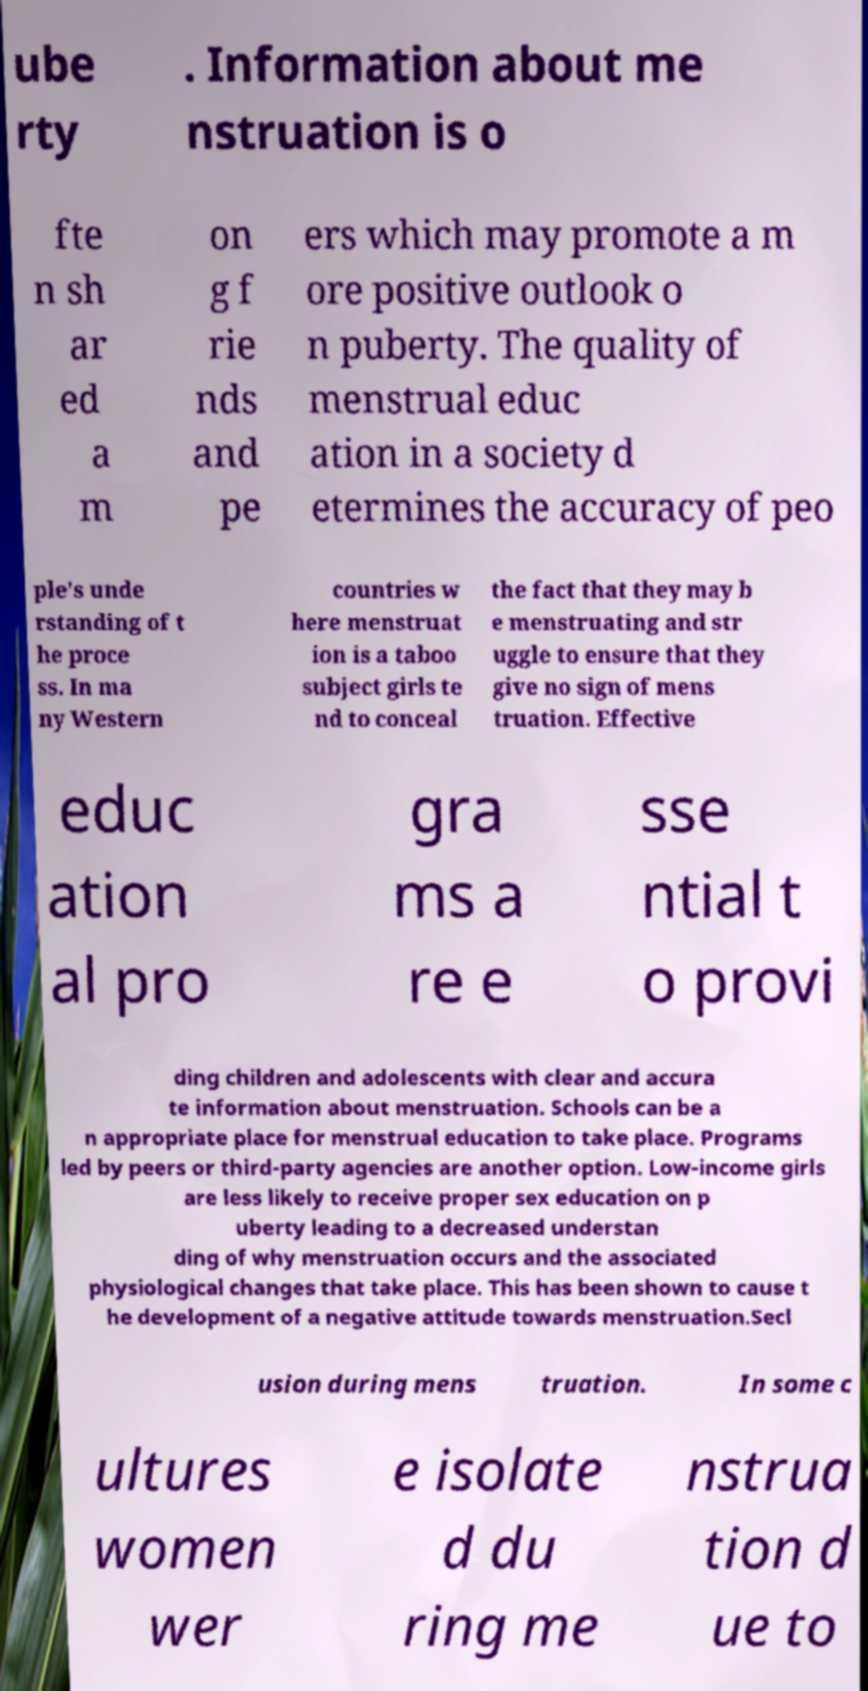Please read and relay the text visible in this image. What does it say? ube rty . Information about me nstruation is o fte n sh ar ed a m on g f rie nds and pe ers which may promote a m ore positive outlook o n puberty. The quality of menstrual educ ation in a society d etermines the accuracy of peo ple's unde rstanding of t he proce ss. In ma ny Western countries w here menstruat ion is a taboo subject girls te nd to conceal the fact that they may b e menstruating and str uggle to ensure that they give no sign of mens truation. Effective educ ation al pro gra ms a re e sse ntial t o provi ding children and adolescents with clear and accura te information about menstruation. Schools can be a n appropriate place for menstrual education to take place. Programs led by peers or third-party agencies are another option. Low-income girls are less likely to receive proper sex education on p uberty leading to a decreased understan ding of why menstruation occurs and the associated physiological changes that take place. This has been shown to cause t he development of a negative attitude towards menstruation.Secl usion during mens truation. In some c ultures women wer e isolate d du ring me nstrua tion d ue to 